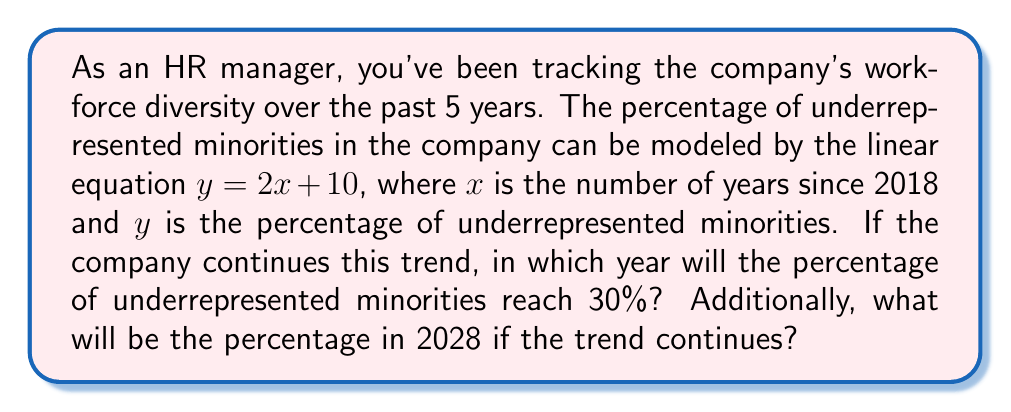Can you answer this question? Let's approach this problem step by step:

1) We're given the linear equation $y = 2x + 10$, where:
   $x$ = number of years since 2018
   $y$ = percentage of underrepresented minorities

2) To find when the percentage will reach 30%, we set $y = 30$ and solve for $x$:

   $$30 = 2x + 10$$
   $$20 = 2x$$
   $$x = 10$$

   This means it will take 10 years from 2018 to reach 30%.

3) To find the year, we add 10 to 2018:
   2018 + 10 = 2028

4) To find the percentage in 2028, we calculate $x$ for 2028:
   2028 is 10 years after 2018, so $x = 10$

   Then we plug this into our equation:
   $$y = 2(10) + 10 = 30$$

   So in 2028, the percentage would be 30%.
Answer: The percentage of underrepresented minorities will reach 30% in 2028. The percentage in 2028 will be 30%. 